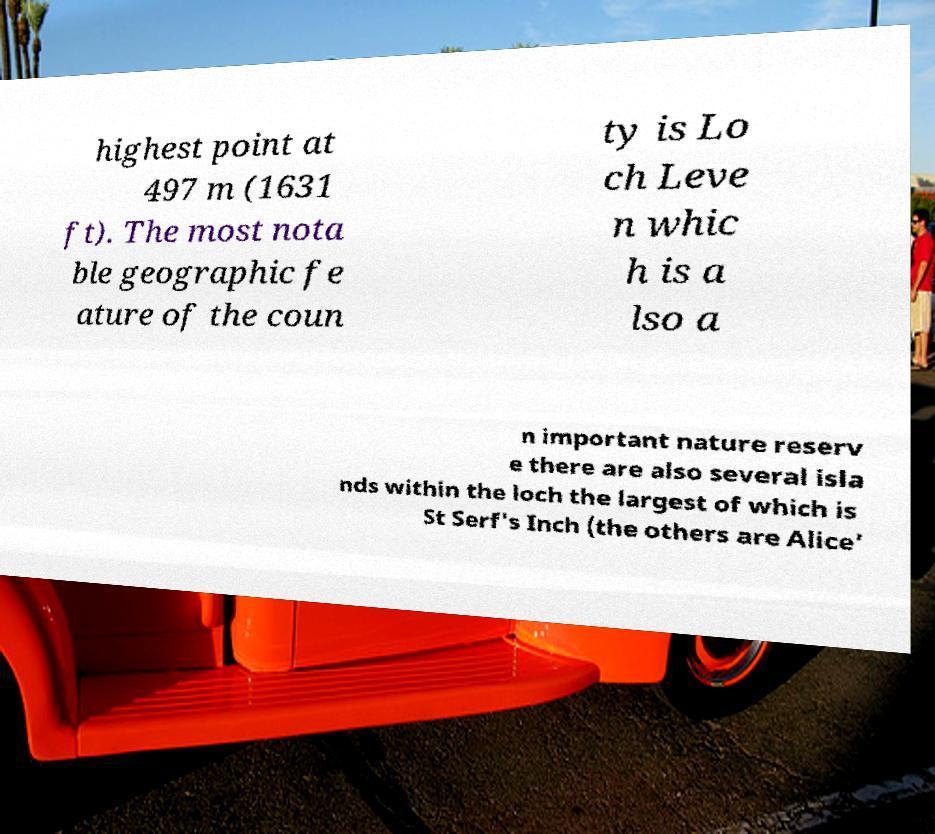Please read and relay the text visible in this image. What does it say? highest point at 497 m (1631 ft). The most nota ble geographic fe ature of the coun ty is Lo ch Leve n whic h is a lso a n important nature reserv e there are also several isla nds within the loch the largest of which is St Serf's Inch (the others are Alice' 